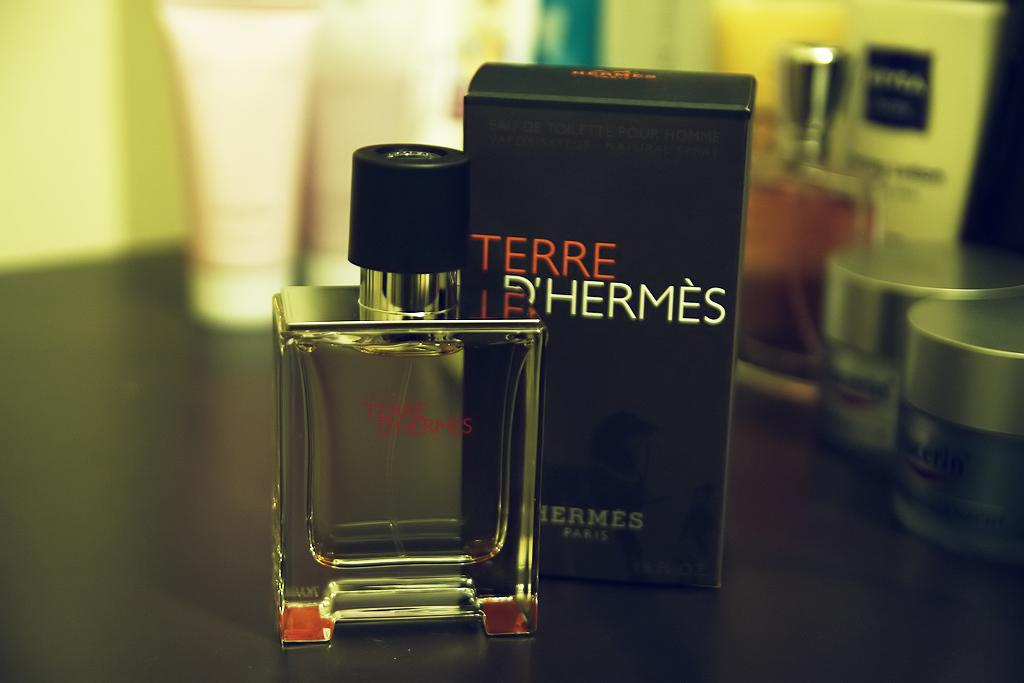<image>
Write a terse but informative summary of the picture. A bottle of Terre D'Hermes sits next to a box. 